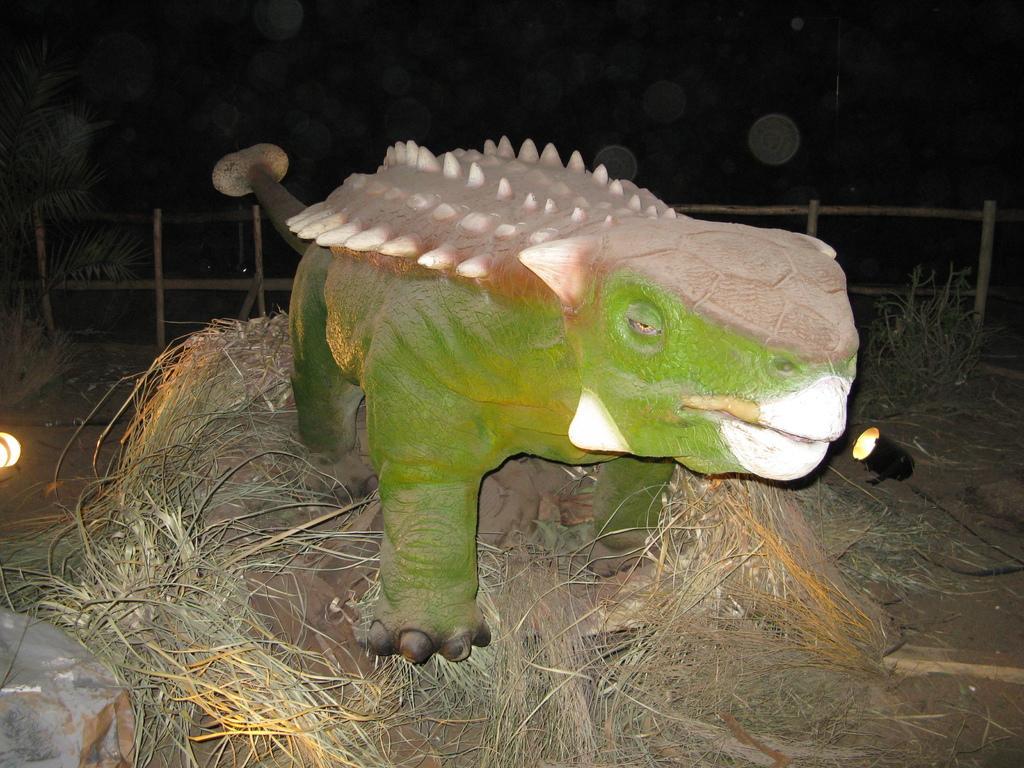In one or two sentences, can you explain what this image depicts? In this image there is an animal that is standing on a grass, in the background there is a fencing. 